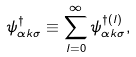<formula> <loc_0><loc_0><loc_500><loc_500>\psi ^ { \dagger } _ { \alpha k \sigma } \equiv \sum _ { l = 0 } ^ { \infty } \psi ^ { \dag ( l ) } _ { \alpha k \sigma } ,</formula> 